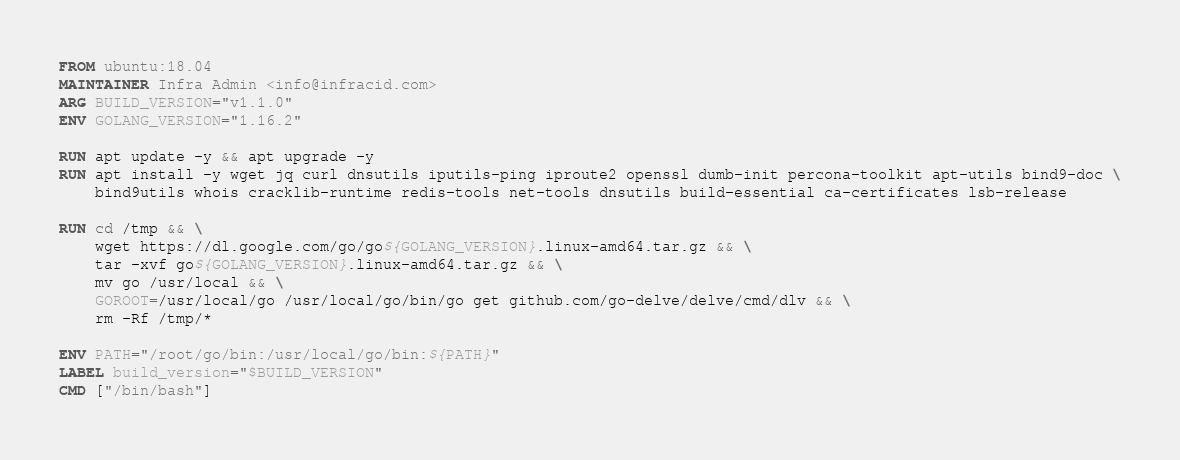<code> <loc_0><loc_0><loc_500><loc_500><_Dockerfile_>FROM ubuntu:18.04
MAINTAINER Infra Admin <info@infracid.com>
ARG BUILD_VERSION="v1.1.0"
ENV GOLANG_VERSION="1.16.2"

RUN apt update -y && apt upgrade -y 
RUN apt install -y wget jq curl dnsutils iputils-ping iproute2 openssl dumb-init percona-toolkit apt-utils bind9-doc \
    bind9utils whois cracklib-runtime redis-tools net-tools dnsutils build-essential ca-certificates lsb-release

RUN cd /tmp && \
    wget https://dl.google.com/go/go${GOLANG_VERSION}.linux-amd64.tar.gz && \
    tar -xvf go${GOLANG_VERSION}.linux-amd64.tar.gz && \
    mv go /usr/local && \
    GOROOT=/usr/local/go /usr/local/go/bin/go get github.com/go-delve/delve/cmd/dlv && \
    rm -Rf /tmp/*

ENV PATH="/root/go/bin:/usr/local/go/bin:${PATH}"
LABEL build_version="$BUILD_VERSION" 
CMD ["/bin/bash"]
</code> 